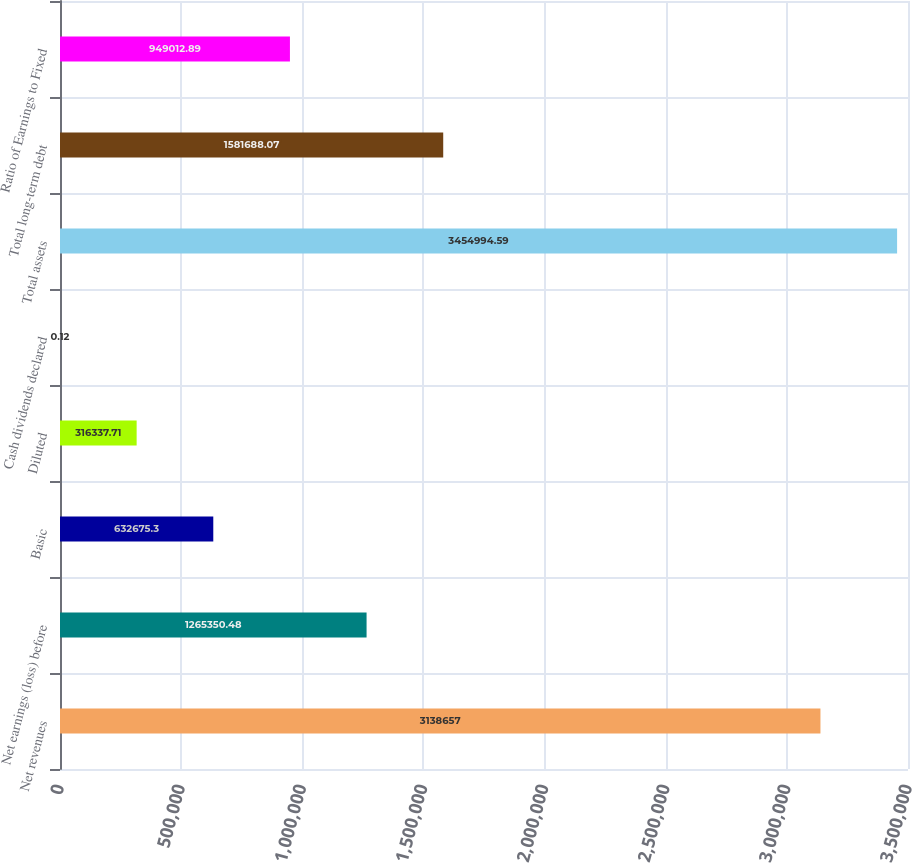<chart> <loc_0><loc_0><loc_500><loc_500><bar_chart><fcel>Net revenues<fcel>Net earnings (loss) before<fcel>Basic<fcel>Diluted<fcel>Cash dividends declared<fcel>Total assets<fcel>Total long-term debt<fcel>Ratio of Earnings to Fixed<nl><fcel>3.13866e+06<fcel>1.26535e+06<fcel>632675<fcel>316338<fcel>0.12<fcel>3.45499e+06<fcel>1.58169e+06<fcel>949013<nl></chart> 